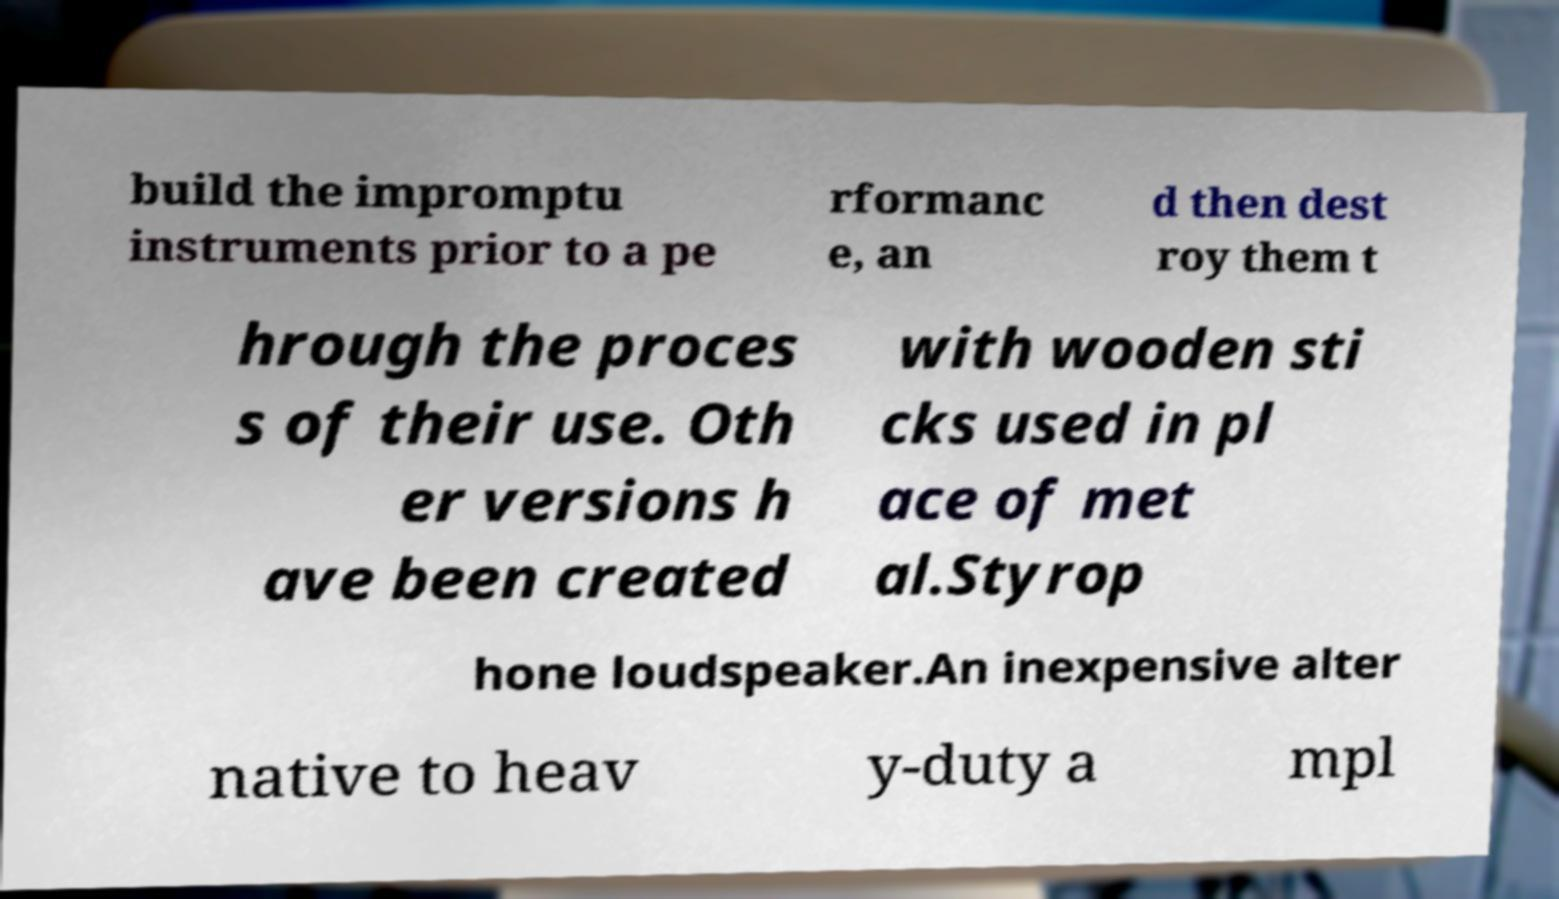Could you extract and type out the text from this image? build the impromptu instruments prior to a pe rformanc e, an d then dest roy them t hrough the proces s of their use. Oth er versions h ave been created with wooden sti cks used in pl ace of met al.Styrop hone loudspeaker.An inexpensive alter native to heav y-duty a mpl 